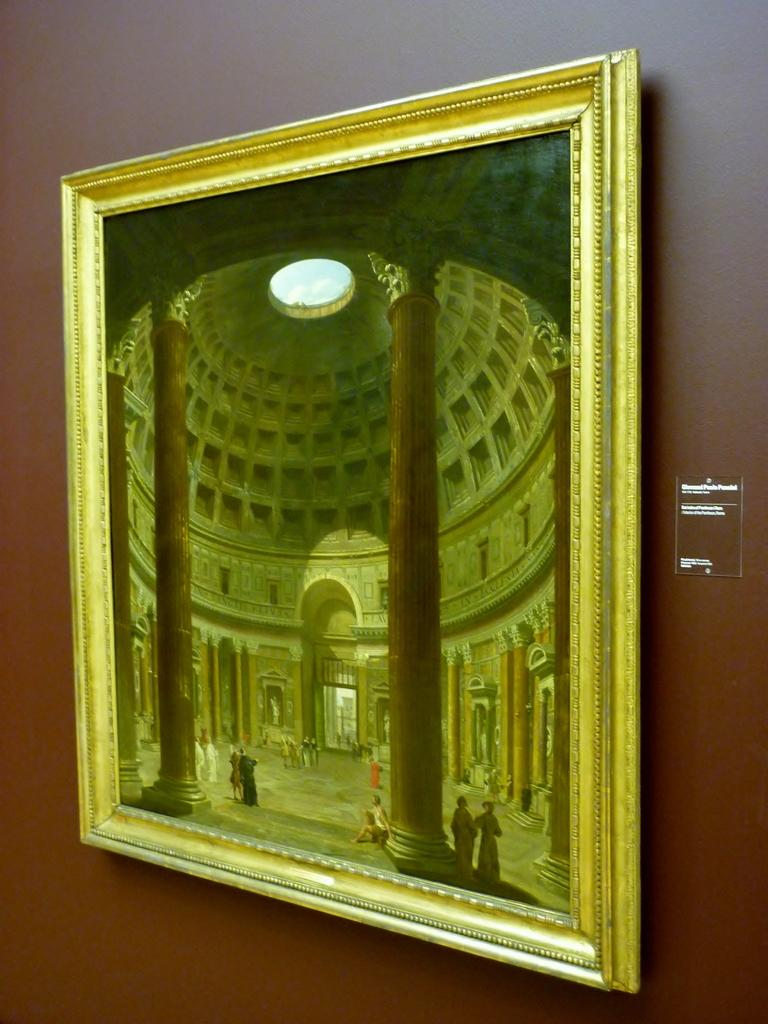What is on the wall in the image? There is a frame on the wall in the image. What architectural features can be seen in the image? There are pillars visible in the image. How many persons are present in the image? There are a few persons in the image. What type of structure is depicted in the image? There is a building in the image. What is the chance of the frame on the wall attacking the persons in the image? The frame on the wall does not have the ability to attack, as it is an inanimate object. What might happen if someone tries to smash the pillars in the image? The question is absurd, as the image does not depict any situation where someone would try to smash the pillars. 